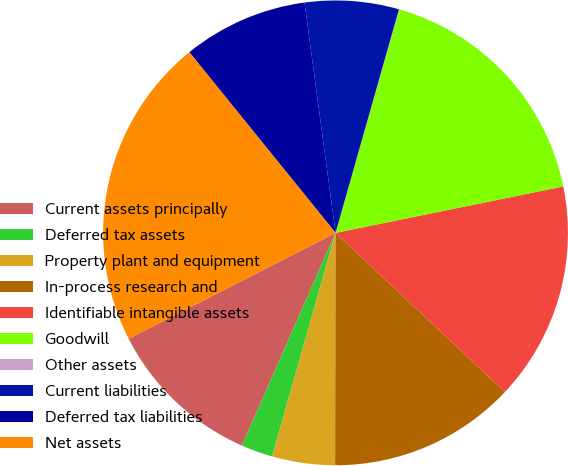<chart> <loc_0><loc_0><loc_500><loc_500><pie_chart><fcel>Current assets principally<fcel>Deferred tax assets<fcel>Property plant and equipment<fcel>In-process research and<fcel>Identifiable intangible assets<fcel>Goodwill<fcel>Other assets<fcel>Current liabilities<fcel>Deferred tax liabilities<fcel>Net assets<nl><fcel>10.87%<fcel>2.2%<fcel>4.37%<fcel>13.03%<fcel>15.2%<fcel>17.37%<fcel>0.03%<fcel>6.53%<fcel>8.7%<fcel>21.7%<nl></chart> 